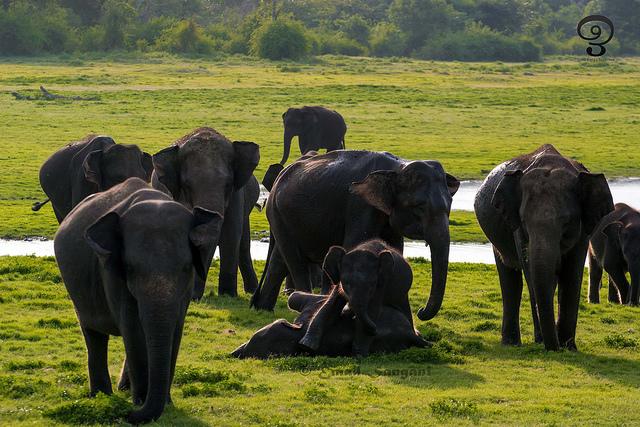What is the color of the elephants?
Quick response, please. Gray. Could this be in the wild?
Write a very short answer. Yes. Is there water?
Short answer required. Yes. 